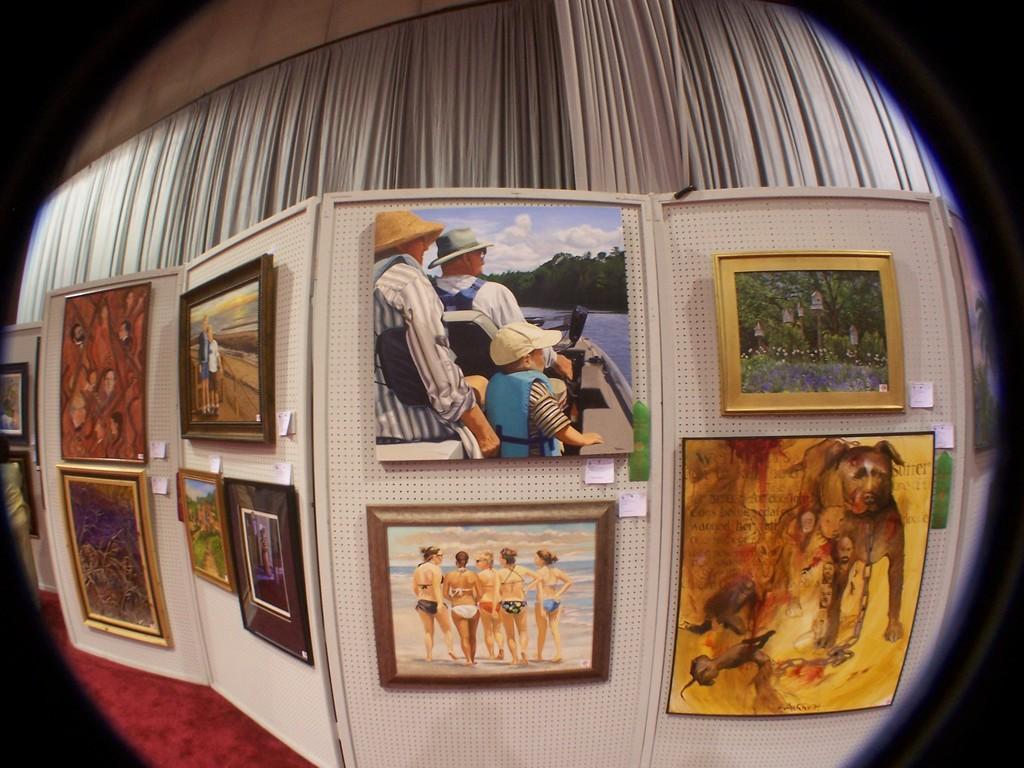How would you summarize this image in a sentence or two? In the center of the image there are many photo frames. In the background of the image there is a curtain. There is a wall. 